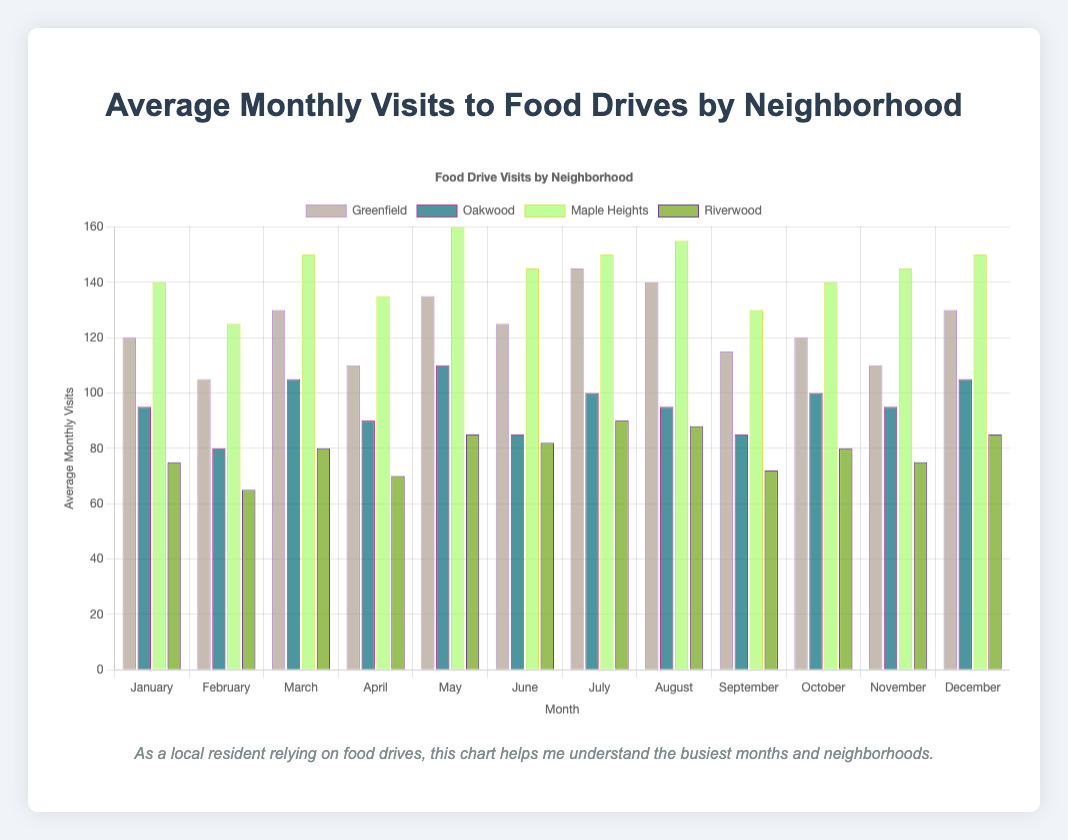Which neighborhood had the highest average monthly visits in July? By looking at the bar heights for each neighborhood in the month of July, we see that Maple Heights has the tallest bar. Therefore, Maple Heights had the highest average monthly visits in July.
Answer: Maple Heights Which month had the lowest average visits in Riverwood? By identifying the shortest bar for Riverwood, we see that February has the fewest visits. The height of the February bar is the least among all months for Riverwood.
Answer: February How many total visits were there in Greenfield for the summer months (June, July, August)? Summing the visits for Greenfield in June (125), July (145), and August (140) gives a total of 125 + 145 + 140 = 410 visits.
Answer: 410 Was the average monthly visit to the food drives in Oakwood higher in March or November? Comparing the heights of the bars for Oakwood in March and November, we see that the March bar is slightly taller (105 visits) than the November bar (95 visits).
Answer: March Which neighborhood had the most significant increase in monthly visits from January to December? Comparing the differences in bar heights from January to December for each neighborhood, we find Greenfield had an increase of 10 visits (120 in January to 130 in December), Oakwood had an increase of 10 visits (95 to 105), Maple Heights had an increase of 10 visits (140 to 150), and Riverwood had an increase of 10 visits (75 to 85). Therefore, all neighborhoods had an equal increase.
Answer: All had equal increases Which month had the highest total visits if we sum across all neighborhoods? Summing the visits for each month across the neighborhoods, we find May has the highest total (Greenfield: 135, Oakwood: 110, Maple Heights: 160, Riverwood: 85), resulting in a total of 135 + 110 + 160 + 85 = 490.
Answer: May During which months did Maple Heights have consistently higher visits compared to Oakwood? By comparing the heights of the bars for each month between Maple Heights and Oakwood, we find that Maple Heights consistently had higher visits across all months as all bars for Maple Heights are taller than those for Oakwood.
Answer: All months Is there any month where visits in Riverwood are higher than in Greenfield? By comparing the heights of the bars for each month between Riverwood and Greenfield, we observe that for every month, the bar for Greenfield is taller than that of Riverwood.
Answer: No What is the difference in the average visits between the busiest and least busy neighborhood for the month of March? For March, Maple Heights (150 visits) is the busiest, and Riverwood (80 visits) is the least busy. The difference is 150 - 80 = 70 visits.
Answer: 70 